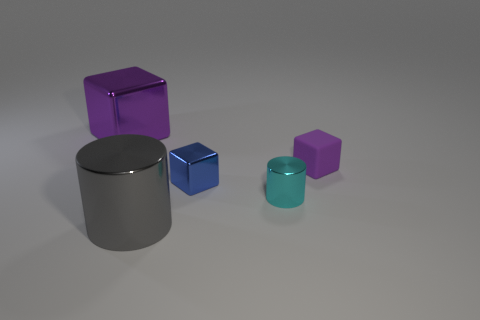What number of cylinders are tiny blue things or tiny metallic objects?
Provide a short and direct response. 1. What is the purple object behind the purple matte object made of?
Ensure brevity in your answer.  Metal. Are there fewer tiny blue metallic cubes than big yellow metal objects?
Your answer should be very brief. No. How big is the shiny object that is both to the left of the blue shiny cube and behind the large gray object?
Provide a short and direct response. Large. There is a shiny object that is behind the metal block in front of the big thing behind the tiny rubber thing; what is its size?
Offer a very short reply. Large. How many other objects are the same color as the matte cube?
Keep it short and to the point. 1. There is a big thing that is right of the large metal block; does it have the same color as the small cylinder?
Your answer should be compact. No. What number of objects are cyan cylinders or big brown matte spheres?
Offer a very short reply. 1. What is the color of the large object on the right side of the big shiny cube?
Ensure brevity in your answer.  Gray. Are there fewer blue things that are behind the big gray object than purple shiny objects?
Keep it short and to the point. No. 